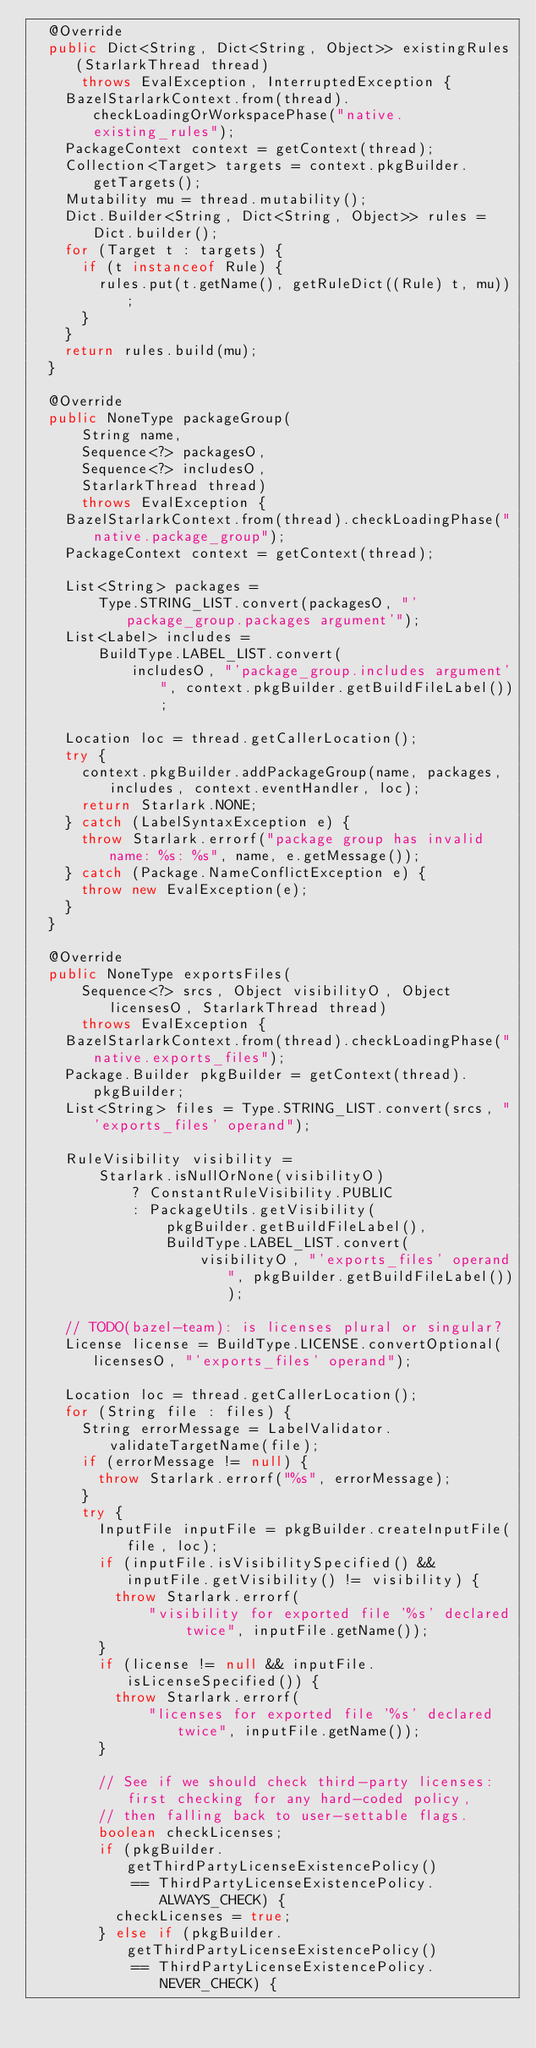Convert code to text. <code><loc_0><loc_0><loc_500><loc_500><_Java_>  @Override
  public Dict<String, Dict<String, Object>> existingRules(StarlarkThread thread)
      throws EvalException, InterruptedException {
    BazelStarlarkContext.from(thread).checkLoadingOrWorkspacePhase("native.existing_rules");
    PackageContext context = getContext(thread);
    Collection<Target> targets = context.pkgBuilder.getTargets();
    Mutability mu = thread.mutability();
    Dict.Builder<String, Dict<String, Object>> rules = Dict.builder();
    for (Target t : targets) {
      if (t instanceof Rule) {
        rules.put(t.getName(), getRuleDict((Rule) t, mu));
      }
    }
    return rules.build(mu);
  }

  @Override
  public NoneType packageGroup(
      String name,
      Sequence<?> packagesO,
      Sequence<?> includesO,
      StarlarkThread thread)
      throws EvalException {
    BazelStarlarkContext.from(thread).checkLoadingPhase("native.package_group");
    PackageContext context = getContext(thread);

    List<String> packages =
        Type.STRING_LIST.convert(packagesO, "'package_group.packages argument'");
    List<Label> includes =
        BuildType.LABEL_LIST.convert(
            includesO, "'package_group.includes argument'", context.pkgBuilder.getBuildFileLabel());

    Location loc = thread.getCallerLocation();
    try {
      context.pkgBuilder.addPackageGroup(name, packages, includes, context.eventHandler, loc);
      return Starlark.NONE;
    } catch (LabelSyntaxException e) {
      throw Starlark.errorf("package group has invalid name: %s: %s", name, e.getMessage());
    } catch (Package.NameConflictException e) {
      throw new EvalException(e);
    }
  }

  @Override
  public NoneType exportsFiles(
      Sequence<?> srcs, Object visibilityO, Object licensesO, StarlarkThread thread)
      throws EvalException {
    BazelStarlarkContext.from(thread).checkLoadingPhase("native.exports_files");
    Package.Builder pkgBuilder = getContext(thread).pkgBuilder;
    List<String> files = Type.STRING_LIST.convert(srcs, "'exports_files' operand");

    RuleVisibility visibility =
        Starlark.isNullOrNone(visibilityO)
            ? ConstantRuleVisibility.PUBLIC
            : PackageUtils.getVisibility(
                pkgBuilder.getBuildFileLabel(),
                BuildType.LABEL_LIST.convert(
                    visibilityO, "'exports_files' operand", pkgBuilder.getBuildFileLabel()));

    // TODO(bazel-team): is licenses plural or singular?
    License license = BuildType.LICENSE.convertOptional(licensesO, "'exports_files' operand");

    Location loc = thread.getCallerLocation();
    for (String file : files) {
      String errorMessage = LabelValidator.validateTargetName(file);
      if (errorMessage != null) {
        throw Starlark.errorf("%s", errorMessage);
      }
      try {
        InputFile inputFile = pkgBuilder.createInputFile(file, loc);
        if (inputFile.isVisibilitySpecified() && inputFile.getVisibility() != visibility) {
          throw Starlark.errorf(
              "visibility for exported file '%s' declared twice", inputFile.getName());
        }
        if (license != null && inputFile.isLicenseSpecified()) {
          throw Starlark.errorf(
              "licenses for exported file '%s' declared twice", inputFile.getName());
        }

        // See if we should check third-party licenses: first checking for any hard-coded policy,
        // then falling back to user-settable flags.
        boolean checkLicenses;
        if (pkgBuilder.getThirdPartyLicenseExistencePolicy()
            == ThirdPartyLicenseExistencePolicy.ALWAYS_CHECK) {
          checkLicenses = true;
        } else if (pkgBuilder.getThirdPartyLicenseExistencePolicy()
            == ThirdPartyLicenseExistencePolicy.NEVER_CHECK) {</code> 